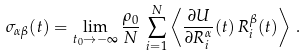<formula> <loc_0><loc_0><loc_500><loc_500>\sigma _ { \alpha \beta } ( t ) = \lim _ { t _ { 0 } \to - \infty } \frac { \rho _ { 0 } } { N } \, \sum _ { i = 1 } ^ { N } \left \langle \frac { \partial U } { \partial R _ { i } ^ { \alpha } } ( t ) \, R _ { i } ^ { \beta } ( t ) \right \rangle \, .</formula> 